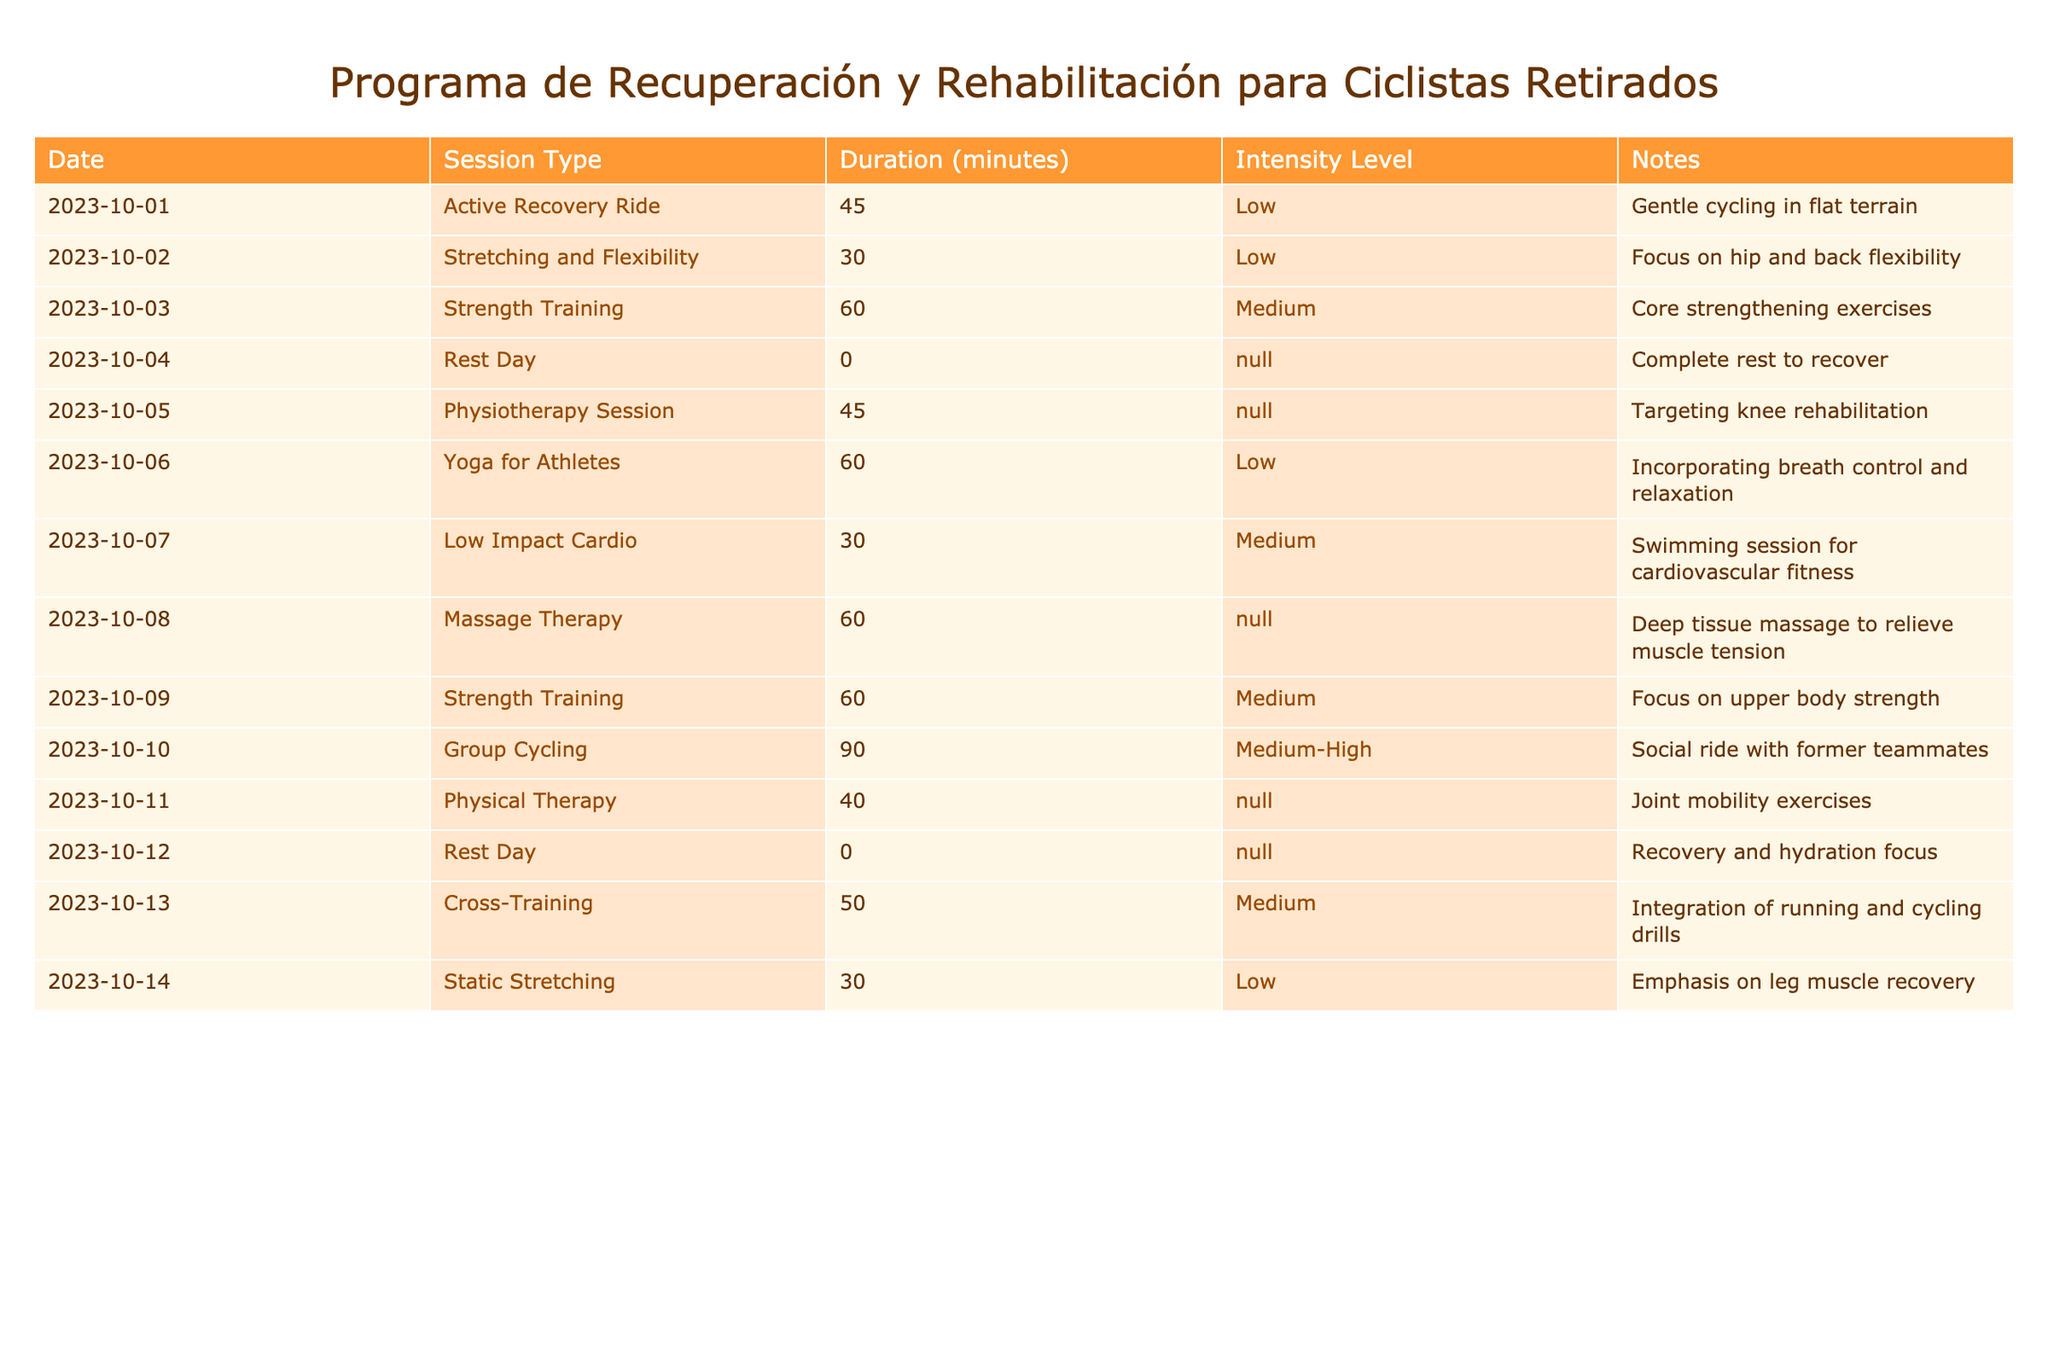What is the total duration of all recorded sessions? To find the total duration, add the durations of all sessions listed in the table: 45 + 30 + 60 + 0 + 45 + 60 + 30 + 60 + 60 + 90 + 40 + 0 + 50 + 30 = 510 minutes.
Answer: 510 minutes How many sessions had medium intensity? Looking at the table, the sessions with medium intensity are Strength Training (twice), Low Impact Cardio, and Cross-Training. That's a total of four sessions.
Answer: 4 sessions What was the longest session type recorded? By examining the durations for each session type, the longest session is Group Cycling, which lasted 90 minutes.
Answer: Group Cycling Did the sessions include any rest days? Observing the table, there are 'Rest Day' entries on 2023-10-04 and 2023-10-12, which confirms that rest days were included in the recovery program.
Answer: Yes What percentage of the sessions were focused on flexibility (Stretching and Flexibility, Yoga for Athletes, Static Stretching)? There are three flexibility-focused sessions (Stretching and Flexibility, Yoga for Athletes, Static Stretching) out of 14 total sessions. The percentage is (3/14) * 100 = 21.43%.
Answer: 21.43% Which session type had the highest duration and what was it? From the table, compare all session durations; Group Cycling had the highest duration at 90 minutes. This is confirmed by checking all listed durations.
Answer: Group Cycling, 90 minutes What is the average duration of the sessions logged? To find the average, sum the durations (510 minutes as previously calculated) and divide by the number of sessions (14). So, 510/14 ≈ 36.43 minutes per session.
Answer: 36.43 minutes How many sessions had an intensity level classified as 'Low'? The 'Low' intensity sessions are Active Recovery Ride, Yoga for Athletes, and Static Stretching. Therefore, there are three sessions with 'Low' intensity.
Answer: 3 sessions Was there more time spent on physiotherapy or strength training? The physiotherapy session lasted 45 minutes, while the two strength training sessions combined for 120 minutes (60 each). Thus, more time was spent on strength training.
Answer: Strength training 